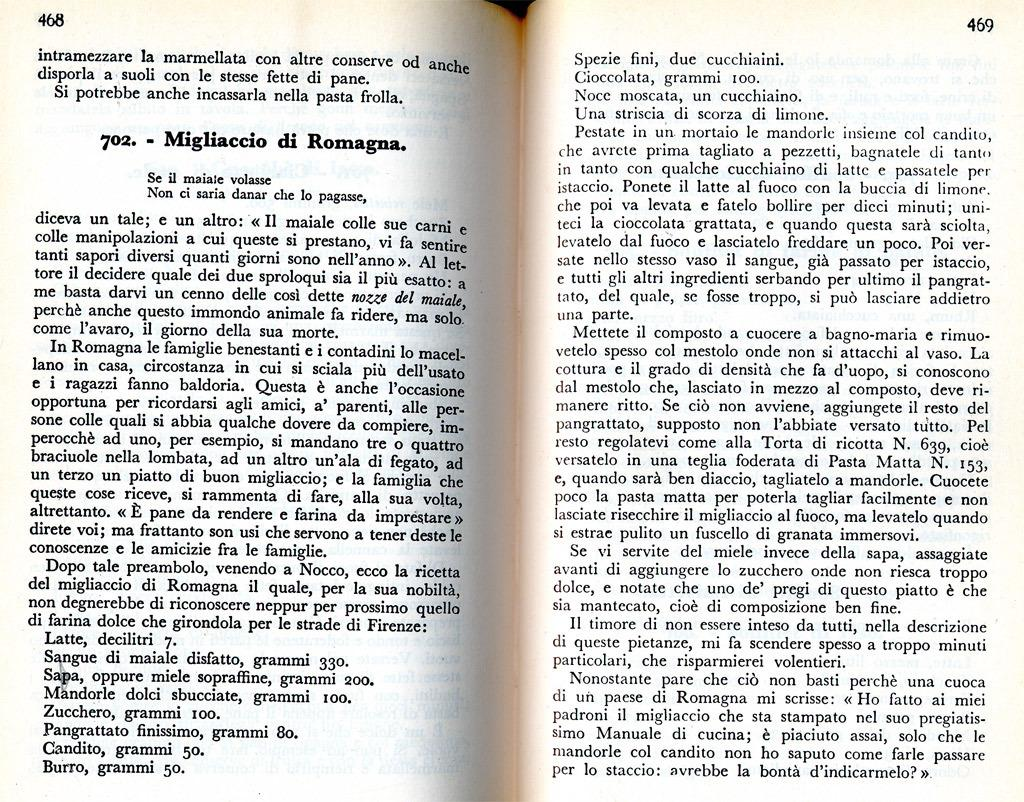<image>
Create a compact narrative representing the image presented. A book is open to page 468 and the page begins with the word intramezzare. 